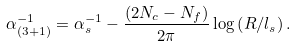<formula> <loc_0><loc_0><loc_500><loc_500>\alpha ^ { - 1 } _ { ( 3 + 1 ) } = \alpha _ { s } ^ { - 1 } - \frac { ( 2 N _ { c } - N _ { f } ) } { 2 \pi } \log \left ( R / l _ { s } \right ) .</formula> 